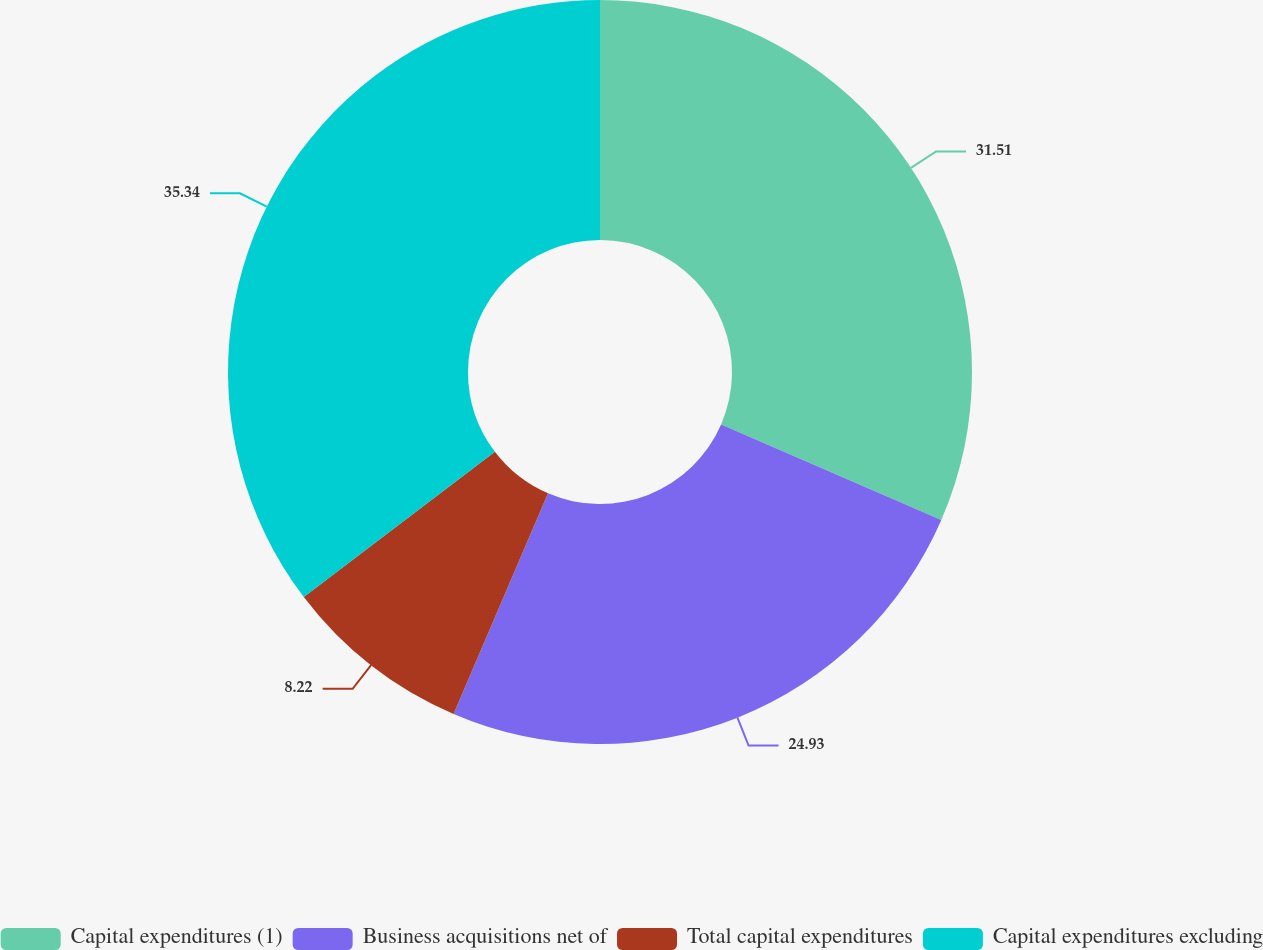<chart> <loc_0><loc_0><loc_500><loc_500><pie_chart><fcel>Capital expenditures (1)<fcel>Business acquisitions net of<fcel>Total capital expenditures<fcel>Capital expenditures excluding<nl><fcel>31.51%<fcel>24.93%<fcel>8.22%<fcel>35.34%<nl></chart> 